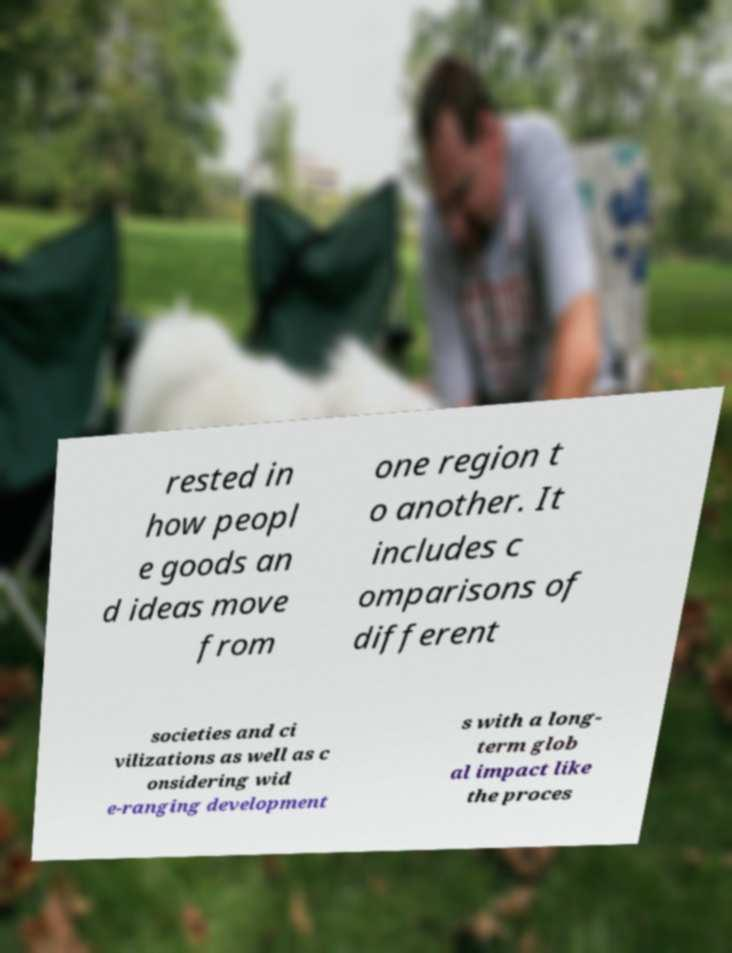Can you accurately transcribe the text from the provided image for me? rested in how peopl e goods an d ideas move from one region t o another. It includes c omparisons of different societies and ci vilizations as well as c onsidering wid e-ranging development s with a long- term glob al impact like the proces 